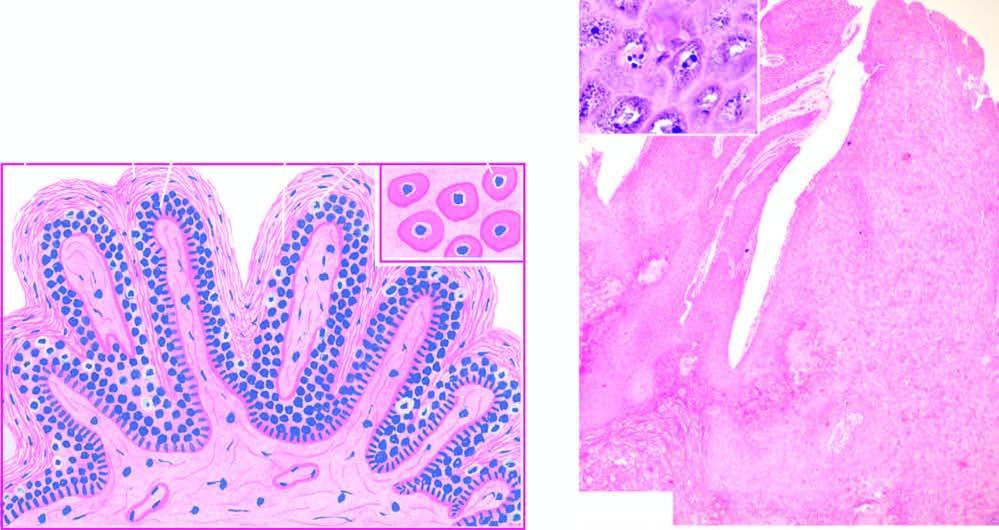did koilocytes and virus-infected keratinocytes contain prominent keratohyaline granules?
Answer the question using a single word or phrase. Yes 